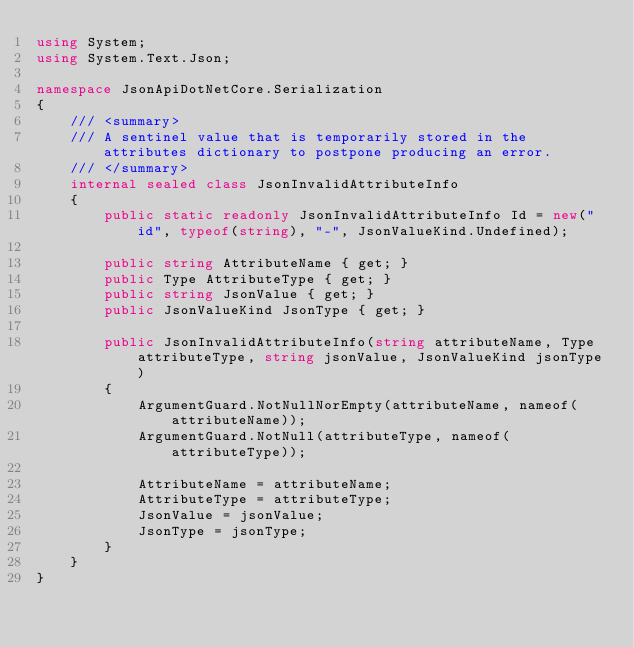<code> <loc_0><loc_0><loc_500><loc_500><_C#_>using System;
using System.Text.Json;

namespace JsonApiDotNetCore.Serialization
{
    /// <summary>
    /// A sentinel value that is temporarily stored in the attributes dictionary to postpone producing an error.
    /// </summary>
    internal sealed class JsonInvalidAttributeInfo
    {
        public static readonly JsonInvalidAttributeInfo Id = new("id", typeof(string), "-", JsonValueKind.Undefined);

        public string AttributeName { get; }
        public Type AttributeType { get; }
        public string JsonValue { get; }
        public JsonValueKind JsonType { get; }

        public JsonInvalidAttributeInfo(string attributeName, Type attributeType, string jsonValue, JsonValueKind jsonType)
        {
            ArgumentGuard.NotNullNorEmpty(attributeName, nameof(attributeName));
            ArgumentGuard.NotNull(attributeType, nameof(attributeType));

            AttributeName = attributeName;
            AttributeType = attributeType;
            JsonValue = jsonValue;
            JsonType = jsonType;
        }
    }
}
</code> 